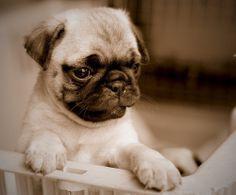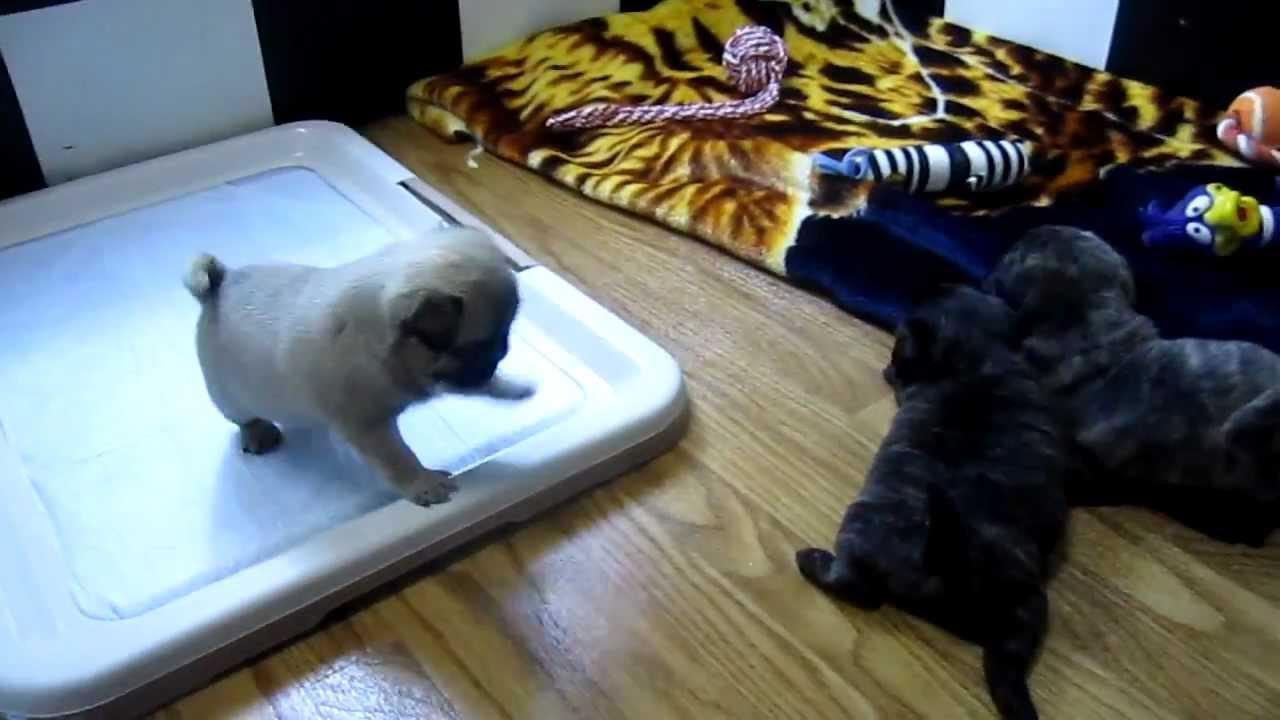The first image is the image on the left, the second image is the image on the right. For the images displayed, is the sentence "The left image contains at least two dogs." factually correct? Answer yes or no. No. 